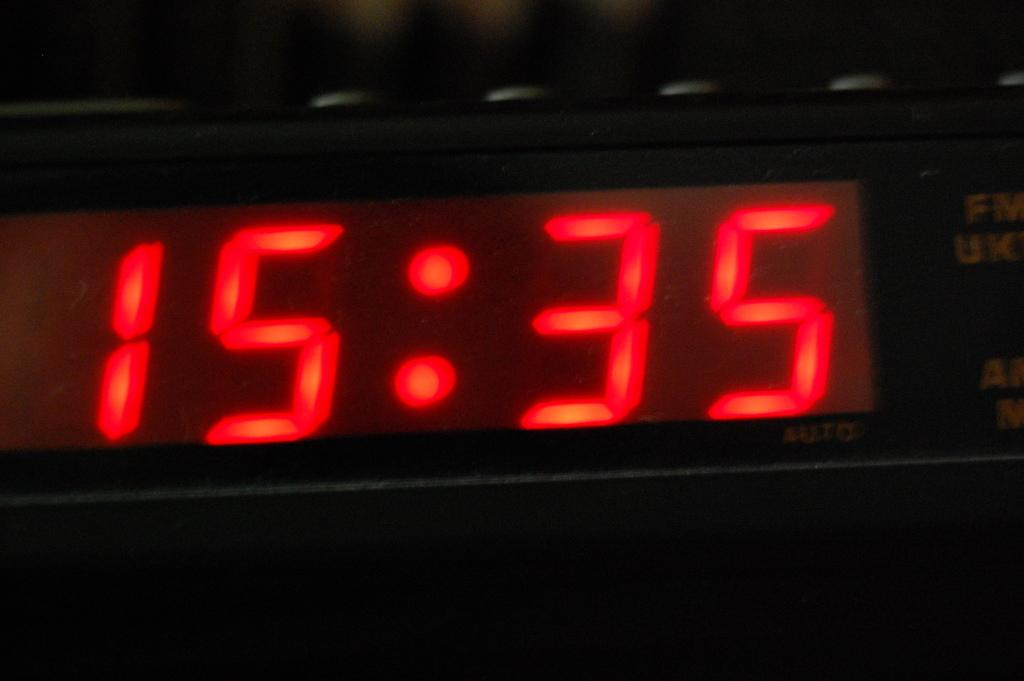<image>
Give a short and clear explanation of the subsequent image. A digital clock shows the 24 hr time as 15:35. 